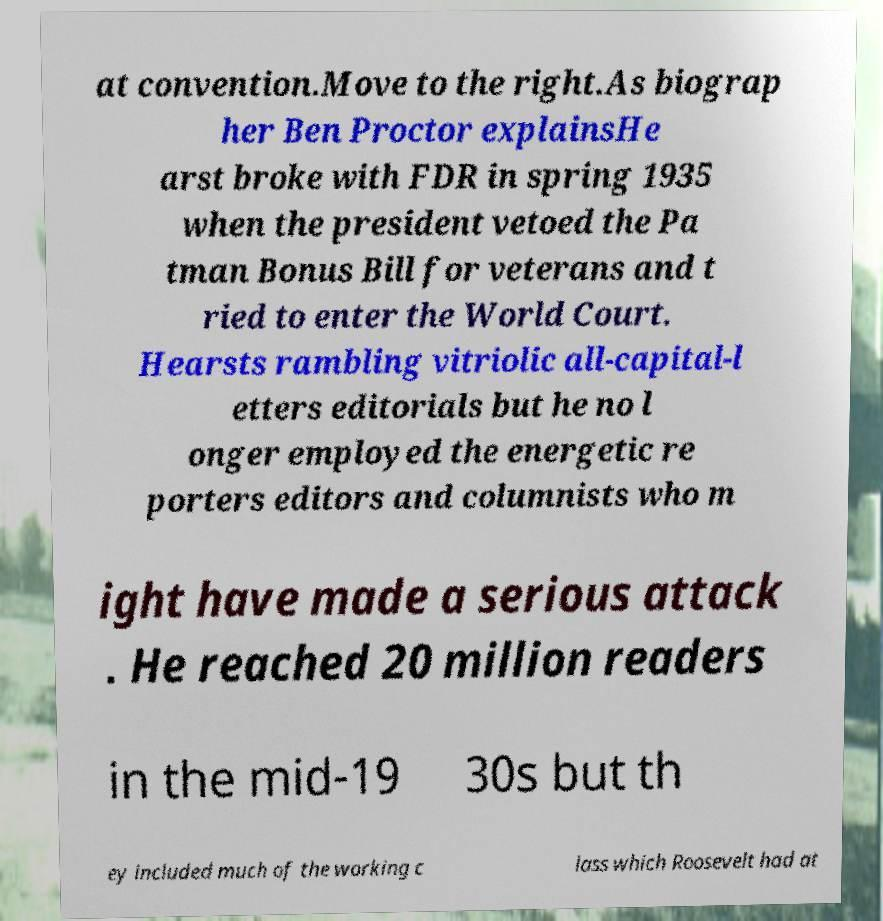Could you extract and type out the text from this image? at convention.Move to the right.As biograp her Ben Proctor explainsHe arst broke with FDR in spring 1935 when the president vetoed the Pa tman Bonus Bill for veterans and t ried to enter the World Court. Hearsts rambling vitriolic all-capital-l etters editorials but he no l onger employed the energetic re porters editors and columnists who m ight have made a serious attack . He reached 20 million readers in the mid-19 30s but th ey included much of the working c lass which Roosevelt had at 